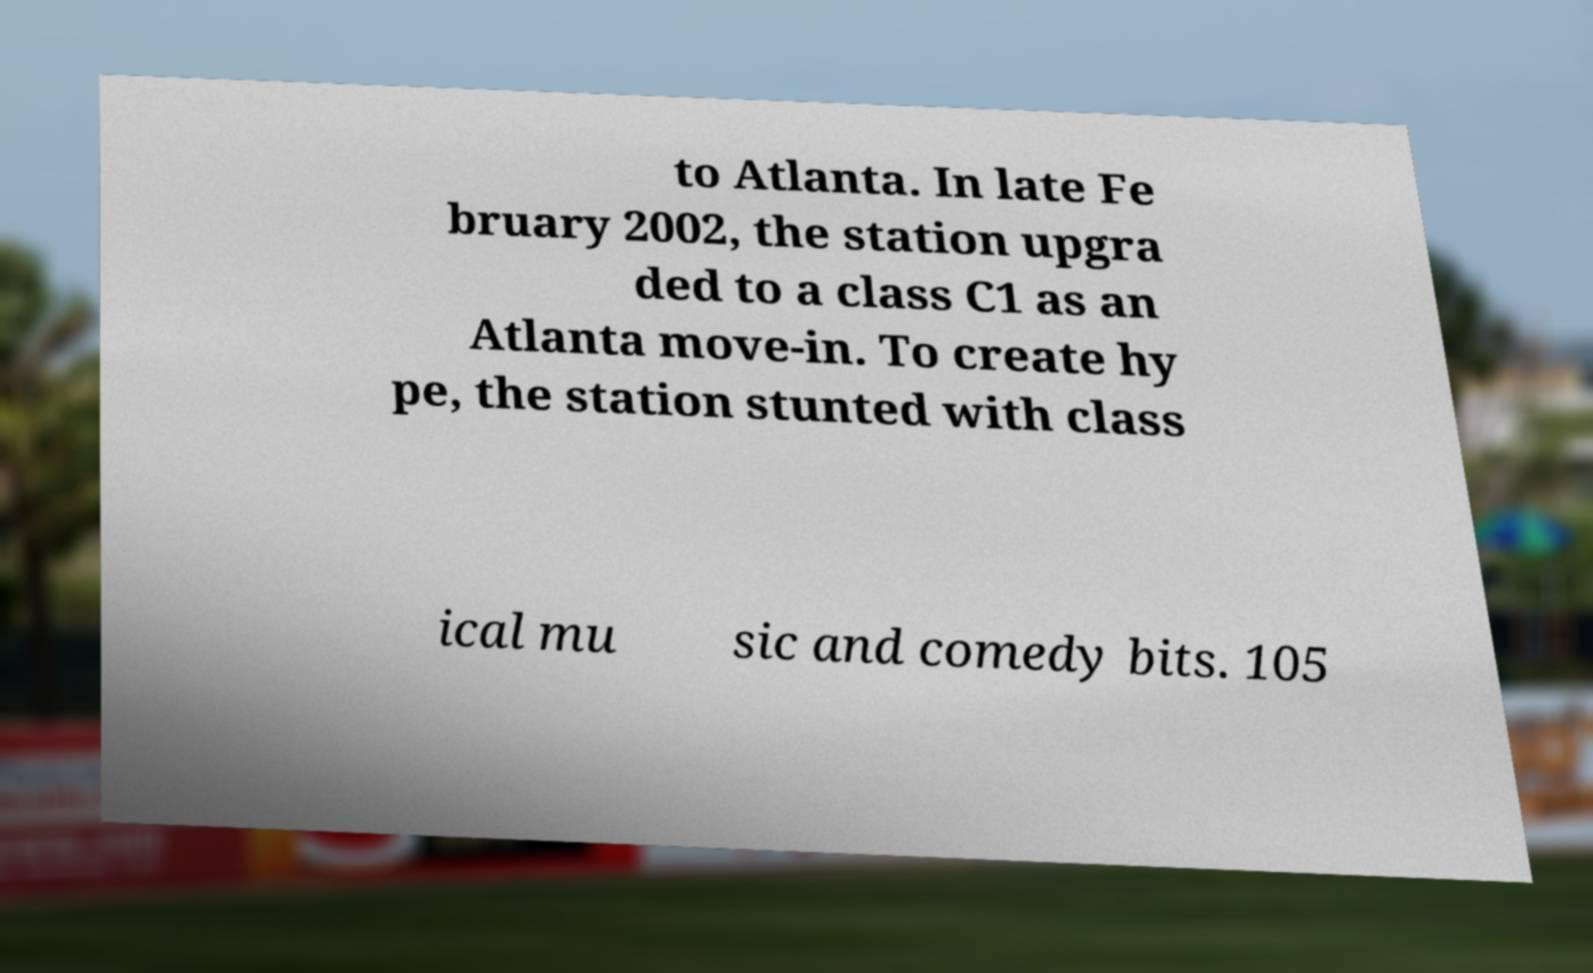Can you read and provide the text displayed in the image?This photo seems to have some interesting text. Can you extract and type it out for me? to Atlanta. In late Fe bruary 2002, the station upgra ded to a class C1 as an Atlanta move-in. To create hy pe, the station stunted with class ical mu sic and comedy bits. 105 